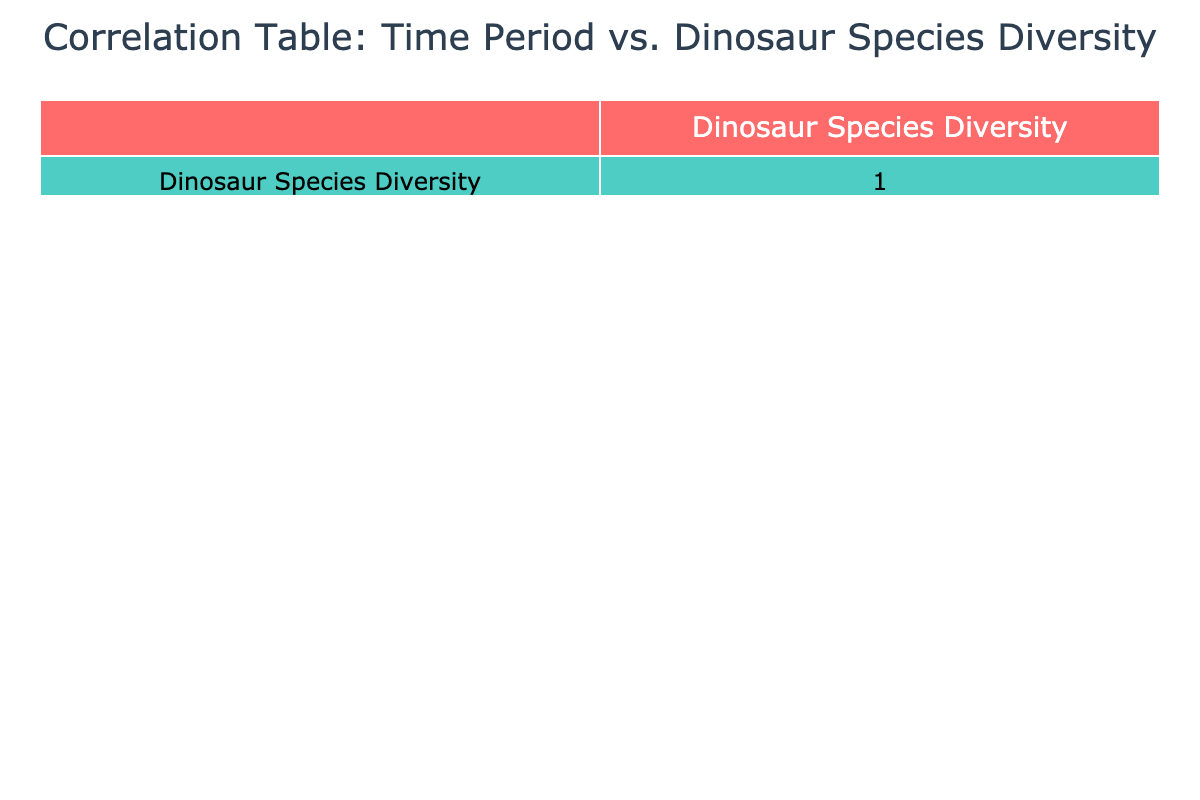What is the dinosaur species diversity during the Jurassic period? Referring to the table, the diversity of dinosaur species during the Jurassic period is listed as 40.
Answer: 40 What is the difference in dinosaur species diversity between the Cretaceous and Triassic periods? The Cretaceous diversity is 75, and the Triassic diversity is 15. The difference is calculated as 75 - 15 = 60.
Answer: 60 Is the dinosaur species diversity higher in the Paleogene than in the Neogene? The table shows that the Paleogene has a diversity of 10, while the Neogene has 5. Since 10 is greater than 5, the statement is true.
Answer: Yes What is the total dinosaur species diversity across all time periods? To find the total, add the diversities: 15 (Triassic) + 40 (Jurassic) + 75 (Cretaceous) + 10 (Paleogene) + 5 (Neogene) = 145.
Answer: 145 What time period has the highest dinosaur species diversity? Looking at the table, the Cretaceous period has the highest diversity listed, which is 75.
Answer: Cretaceous What is the average dinosaur species diversity across the listed time periods? There are 5 time periods, and the total diversity is 145. The average is calculated as 145 / 5 = 29.
Answer: 29 Is the species diversity lowest in the Jurassic period? The Jurassic period has a diversity of 40, while the Neogene has only 5. Since 5 is lower than 40, the statement is false.
Answer: No Which time period shows the most significant decline in species diversity when compared to the Cretaceous? The Neogene has the lowest diversity of 5. To find the decline, we compare: 75 (Cretaceous) - 5 (Neogene) = 70. This represents the highest decline in species diversity.
Answer: Neogene What are the species diversity values of the Triassic and Paleogene combined? To find the combined value, add the two diversity values: 15 (Triassic) + 10 (Paleogene) = 25.
Answer: 25 